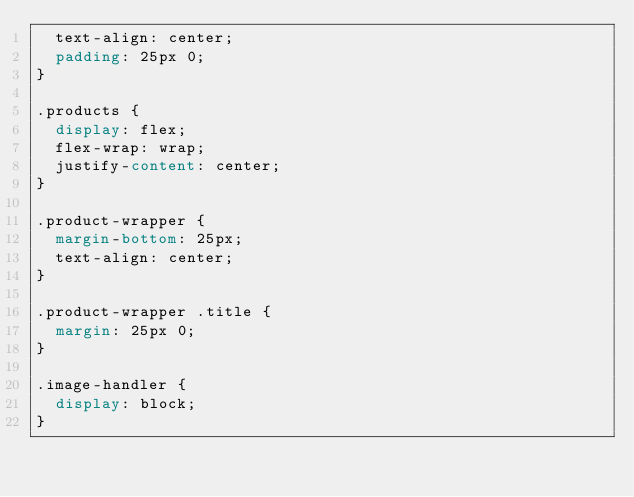<code> <loc_0><loc_0><loc_500><loc_500><_CSS_>  text-align: center;
  padding: 25px 0;
}

.products {
  display: flex;
  flex-wrap: wrap;
  justify-content: center;
}

.product-wrapper {
  margin-bottom: 25px;
  text-align: center;
}

.product-wrapper .title {
  margin: 25px 0;
}

.image-handler {
  display: block;
}

</code> 